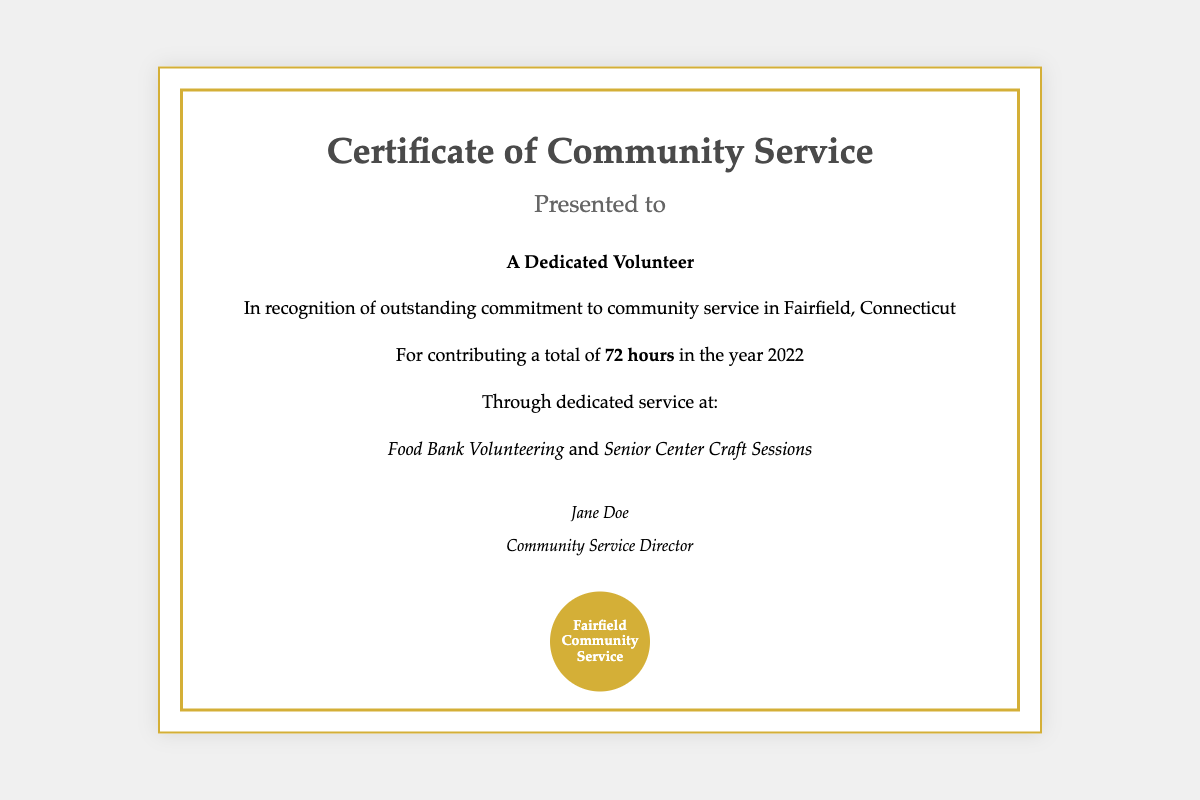What is the title of the document? The title is the main heading that identifies the purpose of the document.
Answer: Certificate of Community Service Who is presented with this certificate? This refers to the individual recognized in the document for their service.
Answer: A Dedicated Volunteer How many hours of community service were contributed? This number represents the total time committed to volunteer activities.
Answer: 72 hours What year is acknowledged for the community service? This refers to the specific year during which the volunteer work was completed.
Answer: 2022 What two specific volunteer activities are mentioned? These are the named activities where the volunteer contributed their time.
Answer: Food Bank Volunteering and Senior Center Craft Sessions Who signed the certificate? This person is the official who recognized the volunteer's contributions.
Answer: Jane Doe What is the title of the person who signed the certificate? This title indicates the role of the individual who signed the certificate.
Answer: Community Service Director What is the color of the seal depicted in the document? This describes the color used in the graphical representation of the seal.
Answer: Gold 